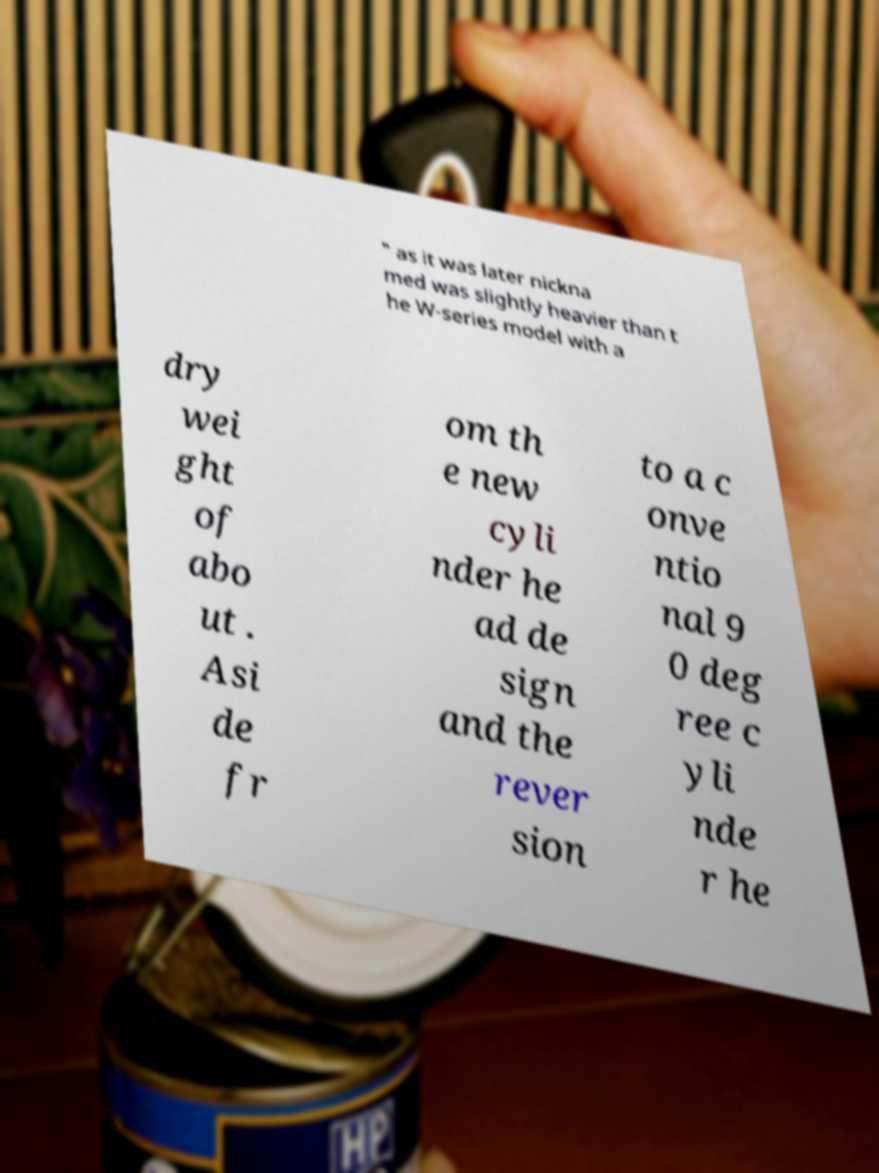Please identify and transcribe the text found in this image. " as it was later nickna med was slightly heavier than t he W-series model with a dry wei ght of abo ut . Asi de fr om th e new cyli nder he ad de sign and the rever sion to a c onve ntio nal 9 0 deg ree c yli nde r he 